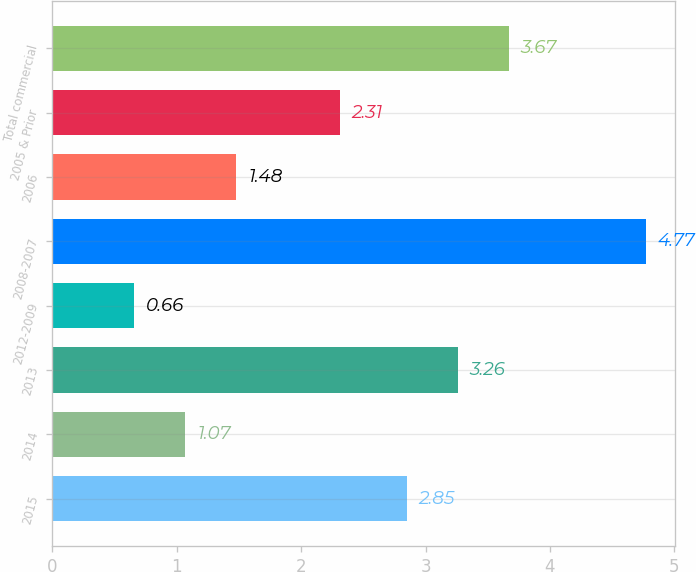Convert chart. <chart><loc_0><loc_0><loc_500><loc_500><bar_chart><fcel>2015<fcel>2014<fcel>2013<fcel>2012-2009<fcel>2008-2007<fcel>2006<fcel>2005 & Prior<fcel>Total commercial<nl><fcel>2.85<fcel>1.07<fcel>3.26<fcel>0.66<fcel>4.77<fcel>1.48<fcel>2.31<fcel>3.67<nl></chart> 